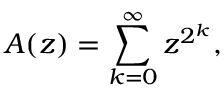<formula> <loc_0><loc_0><loc_500><loc_500>A ( z ) = \sum _ { k = 0 } ^ { \infty } z ^ { 2 ^ { k } } ,</formula> 